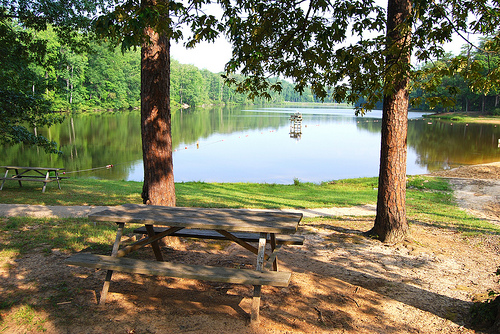<image>
Is there a lake under the tree? Yes. The lake is positioned underneath the tree, with the tree above it in the vertical space. 